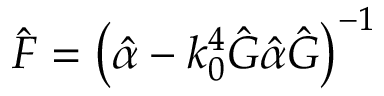<formula> <loc_0><loc_0><loc_500><loc_500>\hat { F } = \left ( \hat { \alpha } - k _ { 0 } ^ { 4 } \hat { G } \hat { \alpha } \hat { G } \right ) ^ { - 1 }</formula> 